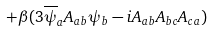<formula> <loc_0><loc_0><loc_500><loc_500>+ \beta ( 3 \overline { \psi } _ { a } A _ { a b } \psi _ { b } - i A _ { a b } A _ { b c } A _ { c a } )</formula> 